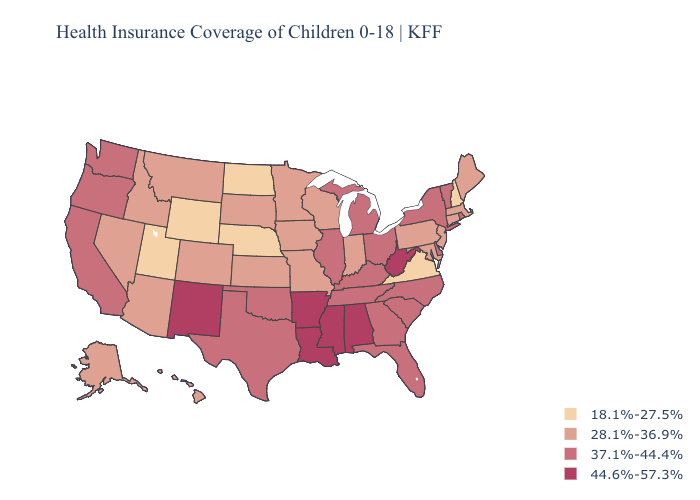How many symbols are there in the legend?
Short answer required. 4. Among the states that border Louisiana , which have the highest value?
Short answer required. Arkansas, Mississippi. What is the highest value in the Northeast ?
Give a very brief answer. 37.1%-44.4%. Which states have the highest value in the USA?
Answer briefly. Alabama, Arkansas, Louisiana, Mississippi, New Mexico, West Virginia. Does Ohio have a higher value than West Virginia?
Concise answer only. No. What is the highest value in the MidWest ?
Be succinct. 37.1%-44.4%. What is the lowest value in the USA?
Concise answer only. 18.1%-27.5%. Does Rhode Island have the same value as Kansas?
Short answer required. No. Among the states that border New York , does Pennsylvania have the highest value?
Answer briefly. No. Does Washington have the same value as Georgia?
Be succinct. Yes. Among the states that border Virginia , which have the highest value?
Be succinct. West Virginia. What is the value of Idaho?
Quick response, please. 28.1%-36.9%. What is the lowest value in the South?
Write a very short answer. 18.1%-27.5%. How many symbols are there in the legend?
Keep it brief. 4. Is the legend a continuous bar?
Concise answer only. No. 